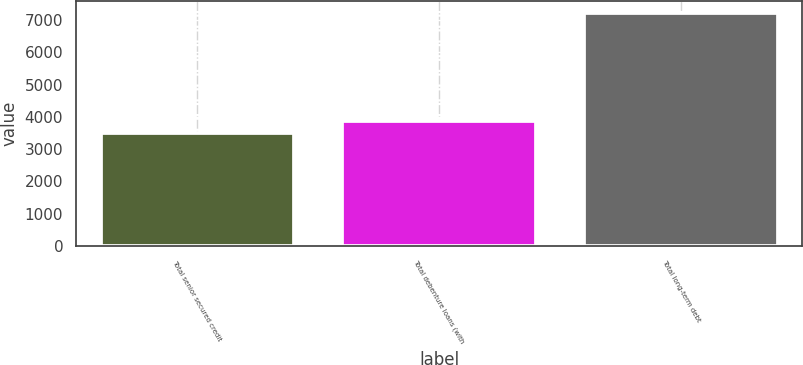<chart> <loc_0><loc_0><loc_500><loc_500><bar_chart><fcel>Total senior secured credit<fcel>Total debenture loans (with<fcel>Total long-term debt<nl><fcel>3497<fcel>3869.5<fcel>7222<nl></chart> 